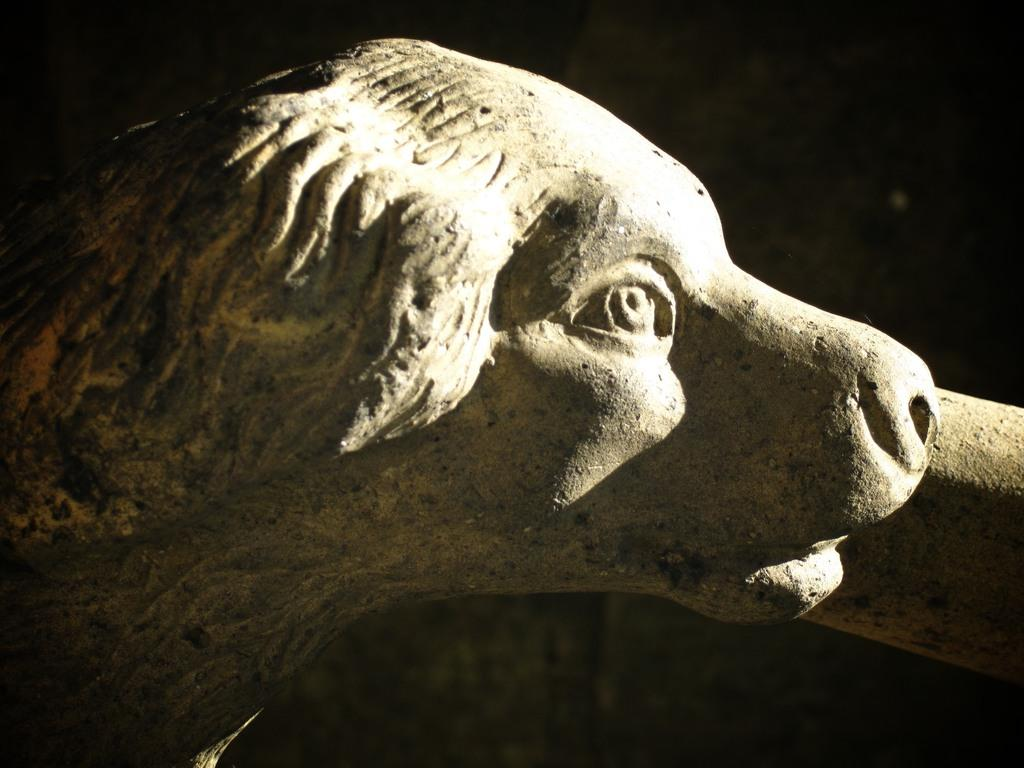What is the main subject of the image? There is a statue of a dog in the image. What can be seen on the statue? There is light on the face of the statue. How would you describe the overall lighting in the image? The background of the image is dark. What type of quiver can be seen hanging on the wall in the image? There is no quiver or wall present in the image; it features a statue of a dog with light on its face against a dark background. 